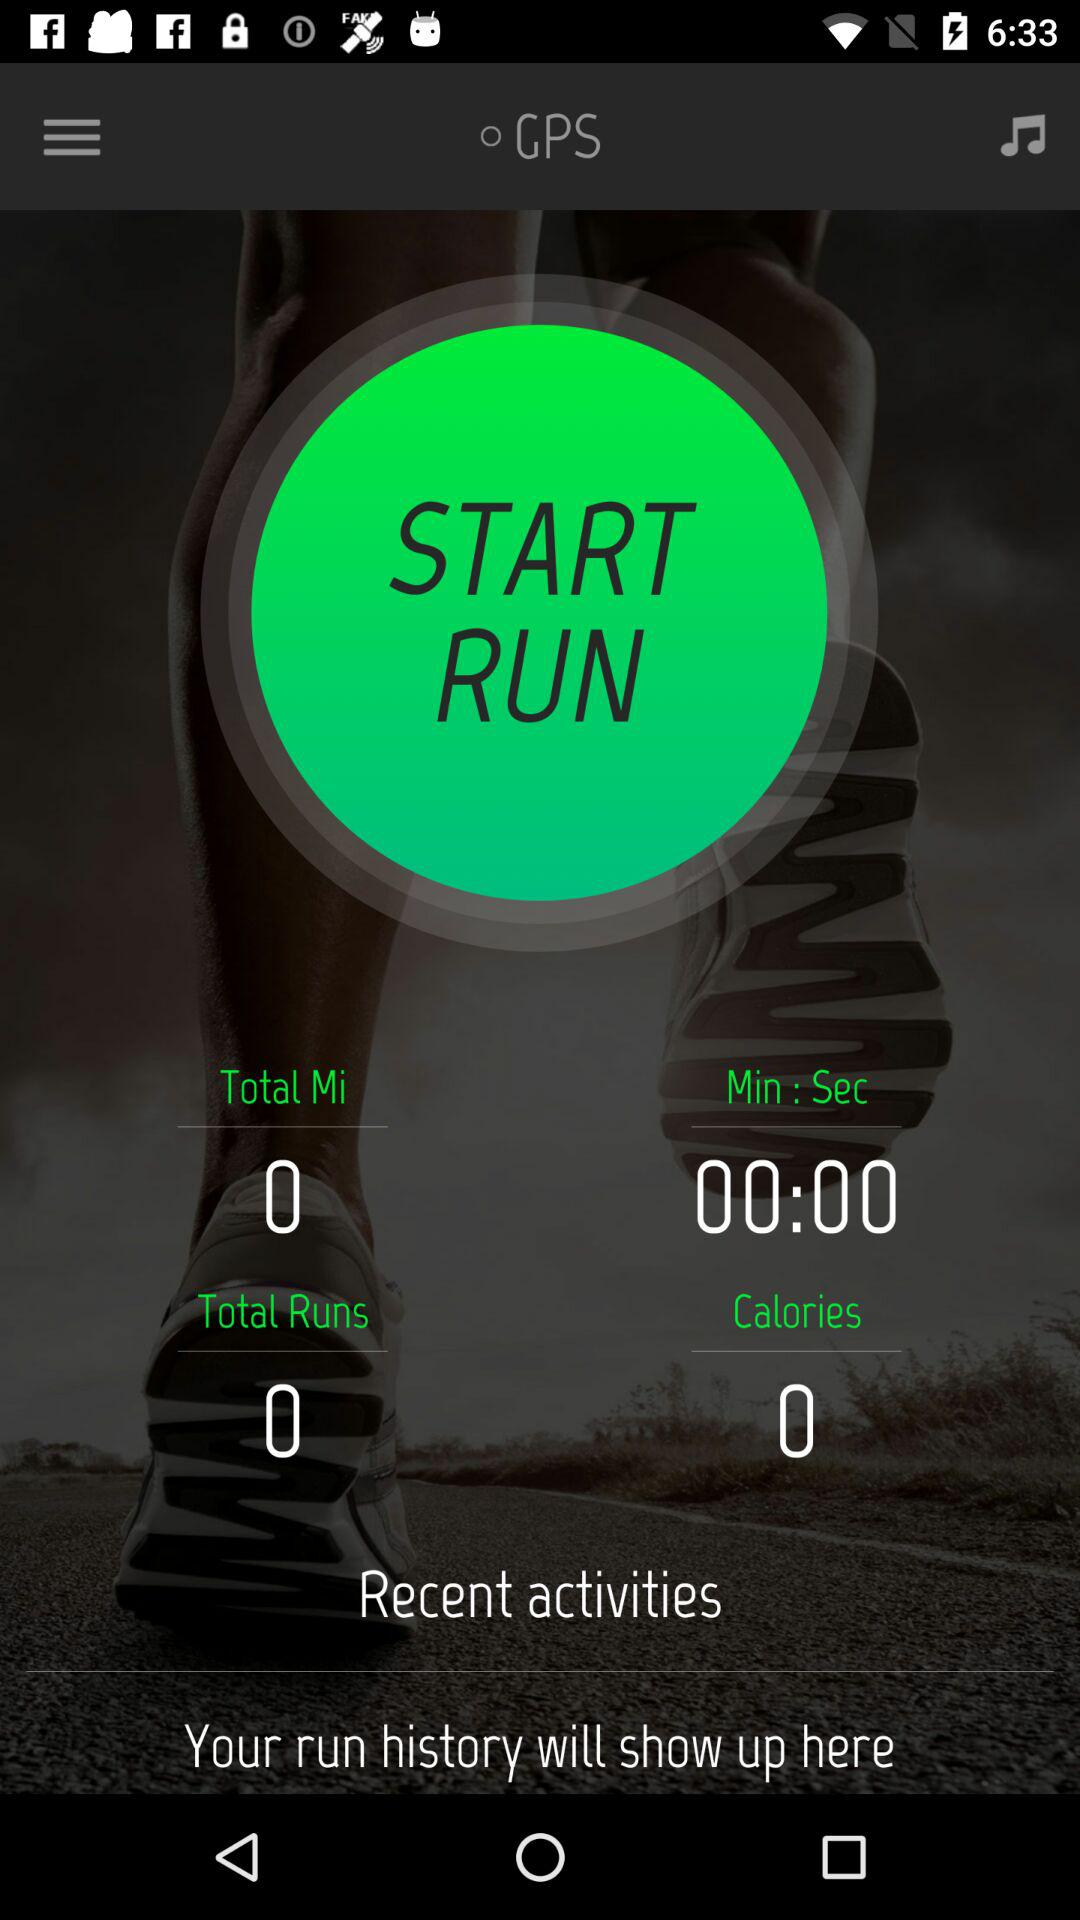What is the total taken time? The total taken time is 0 minutes 0 seconds. 